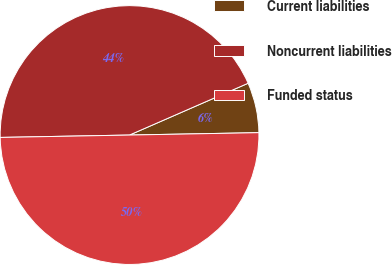<chart> <loc_0><loc_0><loc_500><loc_500><pie_chart><fcel>Current liabilities<fcel>Noncurrent liabilities<fcel>Funded status<nl><fcel>6.26%<fcel>43.74%<fcel>50.0%<nl></chart> 